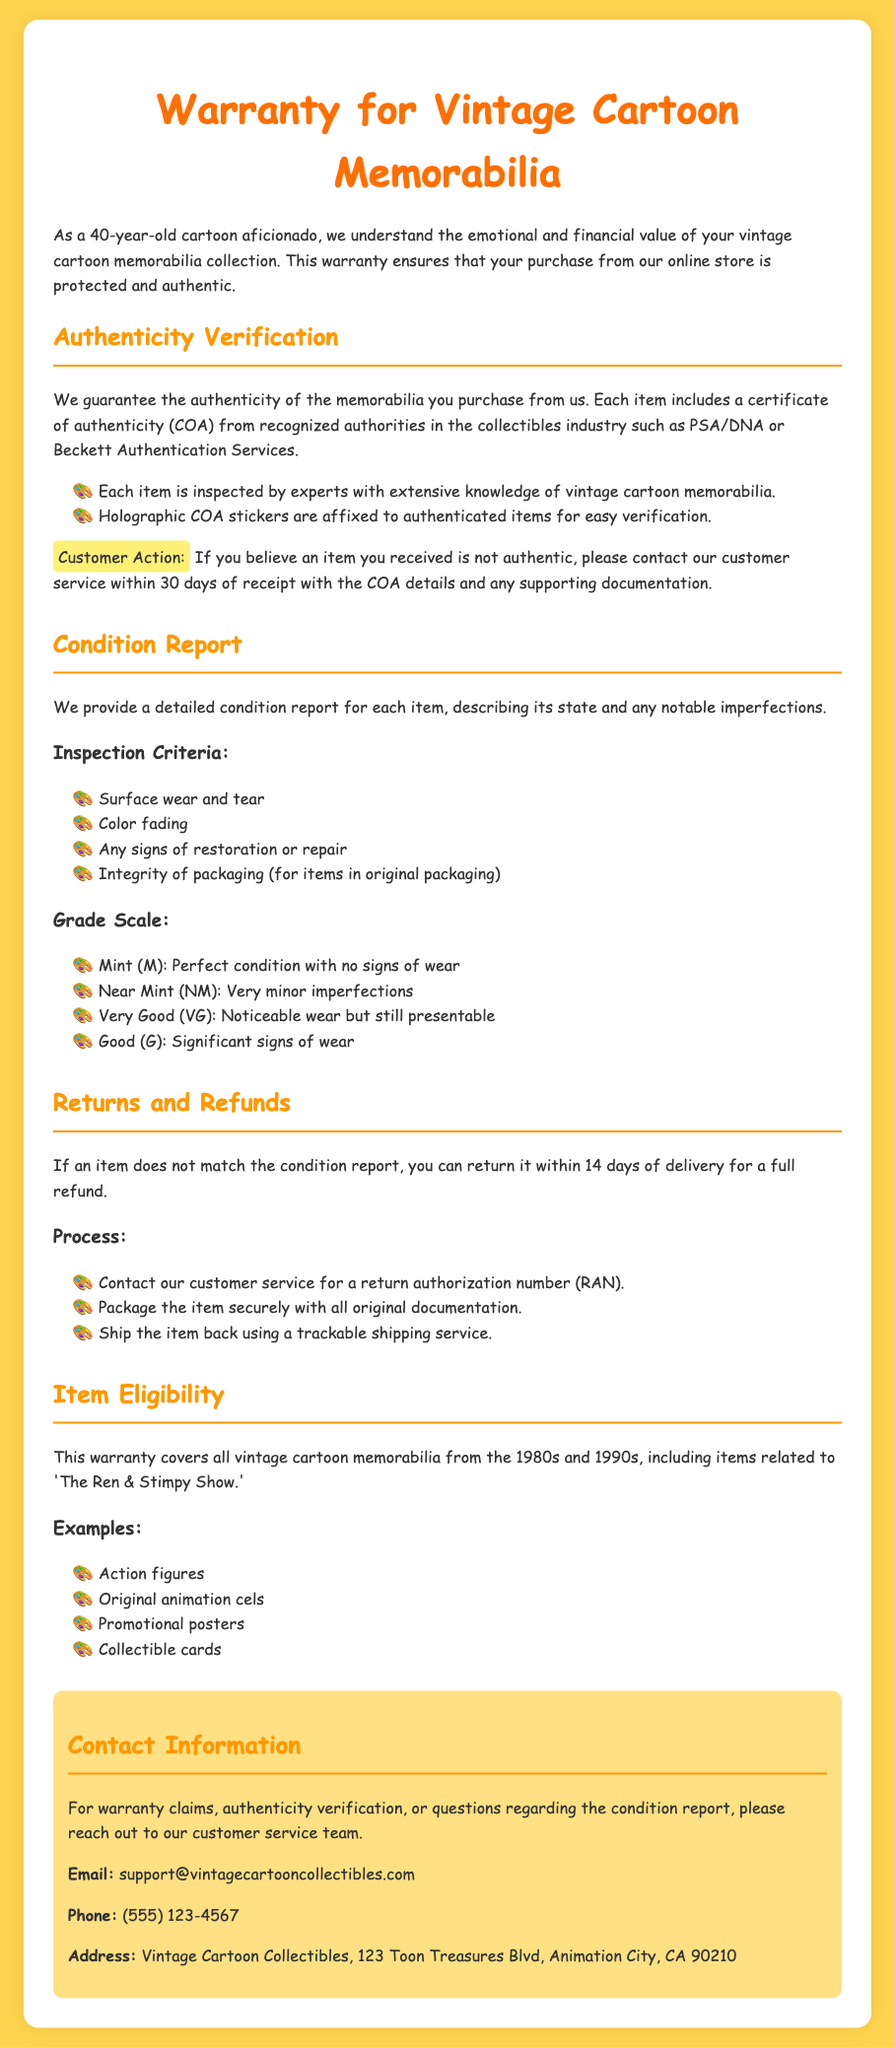What is the warranty period for authenticity claims? The document states that customers must contact customer service within 30 days of receipt for authenticity claims.
Answer: 30 days What must be included for returns? The process for returns specifies that all original documentation must be included when returning an item.
Answer: All original documentation What condition grade indicates perfect condition? The warranty document mentions that "Mint" is the grade that indicates perfect condition with no signs of wear.
Answer: Mint What items are specifically covered by this warranty? The warranty covers all vintage cartoon memorabilia from the 1980s and 1990s, particularly items related to 'The Ren & Stimpy Show.'
Answer: 'The Ren & Stimpy Show' How long do customers have to return an item that does not match the condition report? The document states customers can return items within 14 days of delivery if they do not match the condition report.
Answer: 14 days What authentication services are mentioned in the document? The warranty mentions PSA/DNA and Beckett Authentication Services as recognized authorities in the collectibles industry.
Answer: PSA/DNA or Beckett Authentication Services What is the main color of the document's background? The HTML code indicates that the background color of the document is #ffd54f.
Answer: #ffd54f Who should customers contact for warranty claims? The document emphasizes that customers should reach out to the customer service team for warranty claims.
Answer: Customer service team 